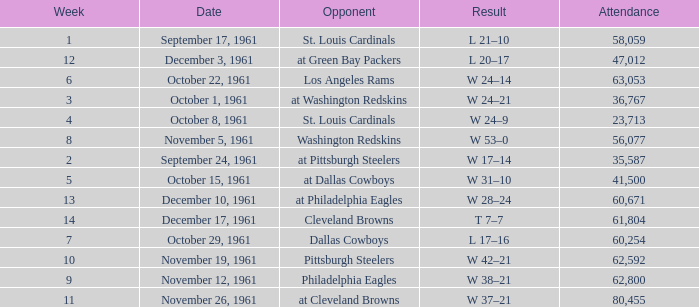What was the result on october 8, 1961? W 24–9. 